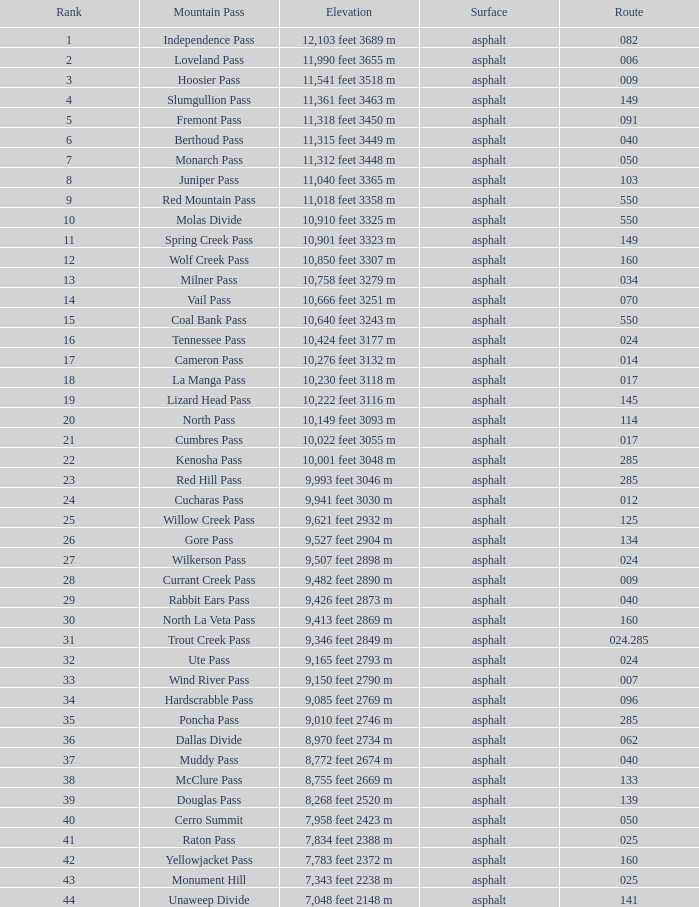What is the Surface of the Route less than 7? Asphalt. 